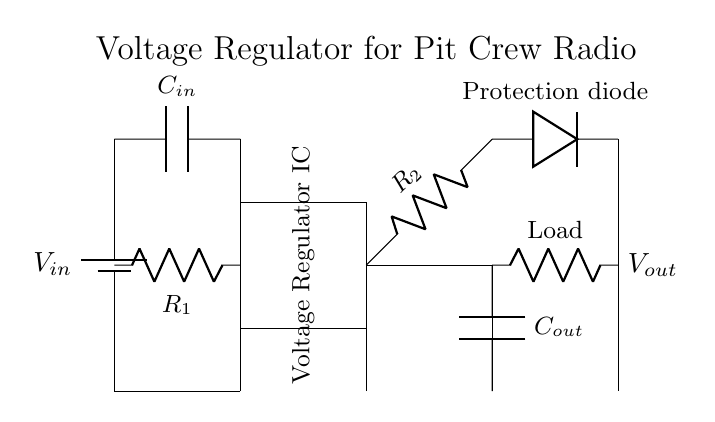What is the input voltage symbol in the circuit? The input voltage is represented by the symbol $V_{in}$ at the top left corner of the circuit diagram. This indicates where the voltage source connects to the circuit.
Answer: V_in What is the purpose of the voltage regulator IC? The voltage regulator IC stabilizes the output voltage to a specific value, ensuring that connected devices receive a consistent voltage regardless of variations in the input voltage or load.
Answer: Stabilization How many capacitors are present in the circuit? There are two capacitors labeled as $C_{in}$ and $C_{out}$. They serve to filter and stabilize the input and output voltages, respectively.
Answer: Two What is the role of the diode in the circuit? The protection diode allows current to flow in one direction, preventing damage to the circuit components from potential reverse voltage conditions.
Answer: Protection What is the output voltage label in the circuit? The output voltage is indicated as $V_{out}$ located on the far right side of the diagram, showing where the regulated voltage is available for use by connected loads.
Answer: V_out Which components determine the voltage drop in this circuit? The resistors $R_1$ and $R_2$ control the voltage drop across the circuit by dividing the input voltage into the necessary regulated output voltage the IC provides for the load.
Answer: R_1 and R_2 What type of load is connected to the circuit? The load is represented symbolically as a resistor, indicating that this circuit powers a resistive load which could be a speaker or a radio transmitter in the communication system.
Answer: Resistor 